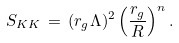<formula> <loc_0><loc_0><loc_500><loc_500>S _ { K K } \, = \, ( r _ { g } \Lambda ) ^ { 2 } \left ( \frac { r _ { g } } { R } \right ) ^ { n } .</formula> 